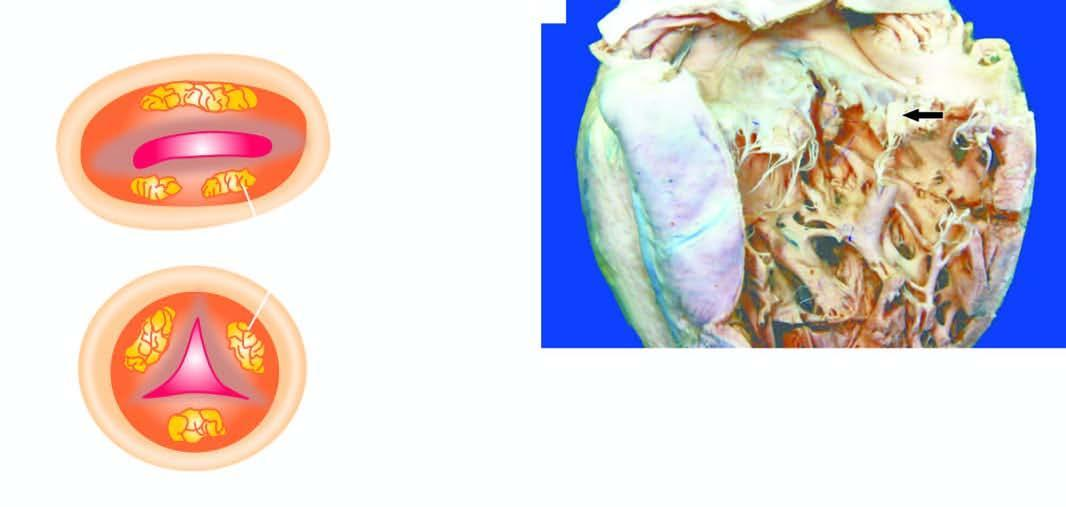where are vegetations?
Answer the question using a single word or phrase. On the valves of the left heart 